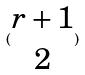<formula> <loc_0><loc_0><loc_500><loc_500>( \begin{matrix} r + 1 \\ 2 \end{matrix} )</formula> 